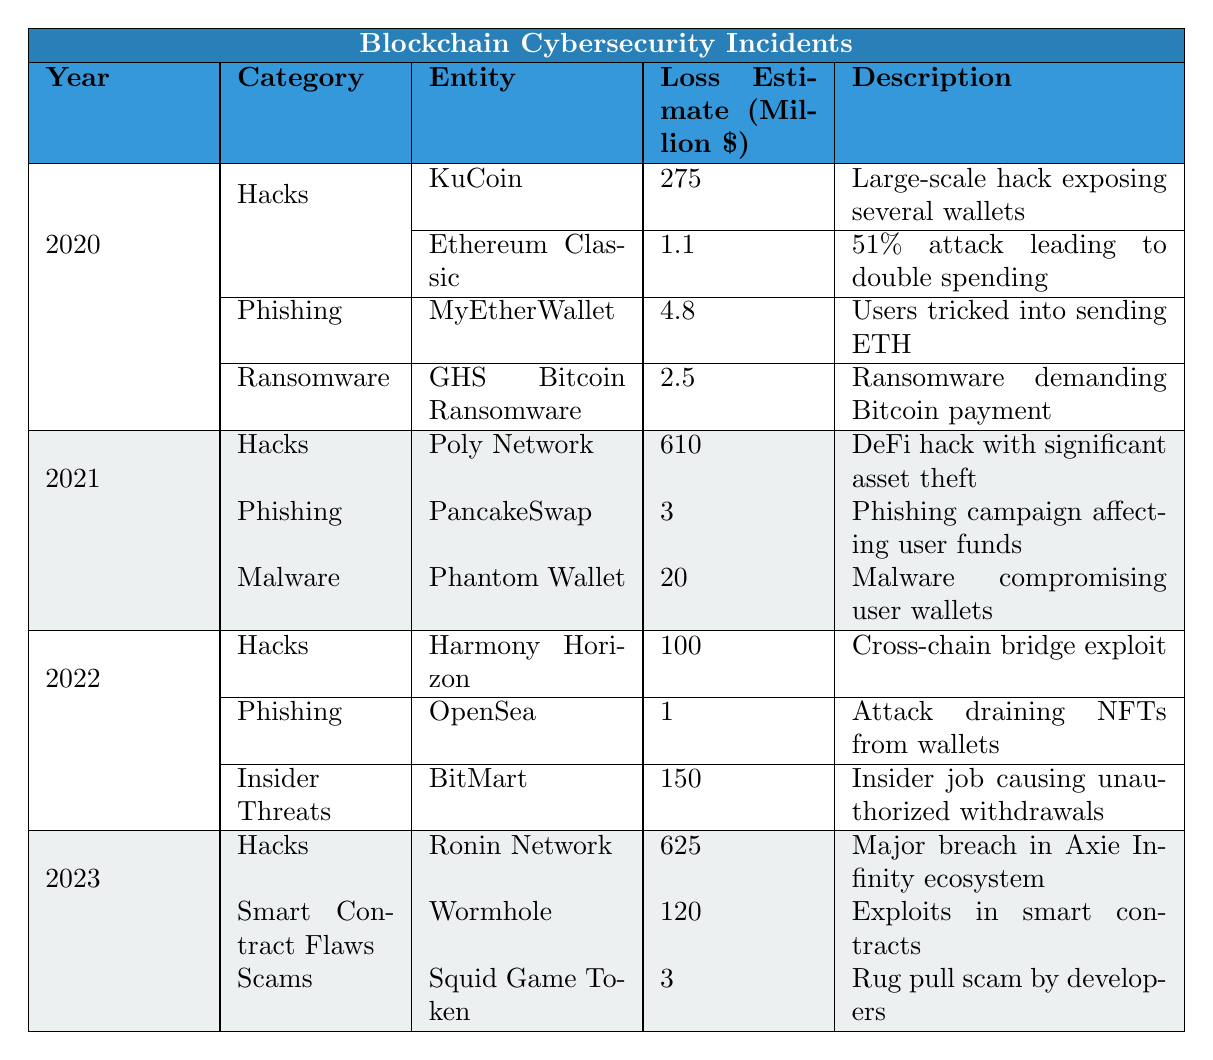What was the largest loss estimate recorded in 2021? By looking at the 2021 section of the table, the largest loss estimate is from the Poly Network hack, which is 610 million dollars.
Answer: 610 million dollars Which year had the highest number of incidents reported? There are four incidents reported in 2020 (3 Hacks, 1 Phishing, 1 Ransomware), three in 2021 (1 Hack, 1 Phishing, 1 Malware), three in 2022 (1 Hack, 1 Phishing, 1 Insider Threat), and three in 2023 (1 Hack, 1 Smart Contract Flaw, 1 Scam). Therefore, 2020 had the highest number of incidents reported.
Answer: 2020 Did any incidents in 2022 exceed a loss of 100 million dollars? By checking the incidents in 2022, only the Hack involving Harmony Horizon exceeded 100 million dollars, with a loss of 100 million dollars. Therefore, the answer is yes.
Answer: Yes What is the total loss estimate for all incidents in 2020? To find the total loss for 2020, we sum the losses: 275 (KuCoin) + 1.1 (Ethereum Classic) + 4.8 (MyEtherWallet) + 2.5 (GHS Bitcoin Ransomware) = 283.4 million dollars.
Answer: 283.4 million dollars Which category in 2023 had the lowest recorded loss estimate? In 2023, the categories were Hacks (625 million), Smart Contract Flaws (120 million), and Scams (3 million). Among these, Scams had the lowest loss estimate at 3 million dollars.
Answer: 3 million dollars Is there any year where all incidents reported were hacks? Upon reviewing the table, there is no year where all incidents were categorized as Hacks; each year displays a mix of different categories.
Answer: No What is the combined loss estimate of hacks across all years? The combined loss estimate for hacks is 275 (2020 KuCoin) + 1.1 (2020 Ethereum Classic) + 610 (2021 Poly Network) + 100 (2022 Harmony Horizon) + 625 (2023 Ronin Network) = 1611.1 million dollars.
Answer: 1611.1 million dollars In which incident category did **OpenSea** fall under and what was the loss estimate? OpenSea was classified under the Phishing category in 2022, and the loss estimate was 1 million dollars.
Answer: Phishing category, 1 million dollars Identify the incident that was classified as **Insider Threat** and provide its loss estimate. The incident classified as Insider Threat is from BitMart in 2022, with a loss estimate of 150 million dollars.
Answer: BitMart, 150 million dollars What is the difference in loss estimates between the highest hack in 2021 and the lowest hack in 2020? The highest hack in 2021 was Poly Network with 610 million dollars, and the lowest hack in 2020 was Ethereum Classic with 1.1 million dollars. The difference is 610 - 1.1 = 608.9 million dollars.
Answer: 608.9 million dollars 